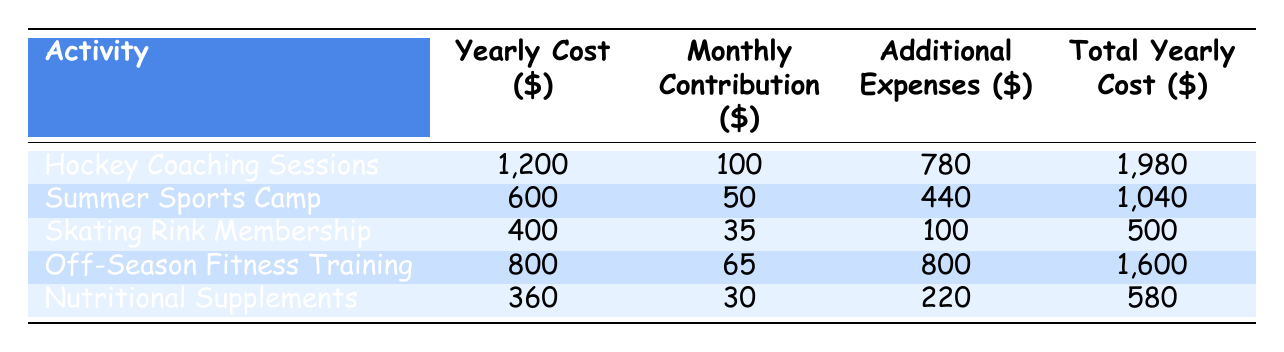What is the total yearly cost for Hockey Coaching Sessions? The table shows the total yearly cost for each activity. For Hockey Coaching Sessions, the total yearly cost is listed as 1980.
Answer: 1980 What is the monthly contribution required for the Skating Rink Membership? Referring to the table, the monthly contribution for the Skating Rink Membership is clearly stated as 35.
Answer: 35 Is the yearly cost for Summer Sports Camp less than the total yearly cost for Nutritional Supplements? The yearly cost for Summer Sports Camp is 600, and the total yearly cost for Nutritional Supplements is 580. Since 600 is greater than 580, the statement is false.
Answer: No What are the additional expenses associated with Off-Season Fitness Training? The table provides the breakdown of additional expenses for Off-Season Fitness Training, which includes Gym Memberships (300), Personal Trainer (400), and Training Equipment (100). Adding these gives a total of 800.
Answer: 800 Which activity has the highest total yearly cost? To find the highest total yearly cost, we compare the total yearly costs for all activities: Hockey Coaching Sessions (1980), Summer Sports Camp (1040), Skating Rink Membership (500), Off-Season Fitness Training (1600), and Nutritional Supplements (580). The highest total is 1980 for Hockey Coaching Sessions.
Answer: Hockey Coaching Sessions What is the average monthly contribution across all activities? First, we need to add the monthly contributions for each activity: 100 (Hockey Coaching) + 50 (Summer Sports Camp) + 35 (Skating Rink) + 65 (Off-Season Training) + 30 (Nutritional Supplements) = 380. There are 5 activities, so the average monthly contribution is 380/5 = 76.
Answer: 76 Are the additional expenses for Nutritional Supplements greater than the additional expenses for Skating Rink Membership? The additional expenses for Nutritional Supplements total 220, while the additional expenses for Skating Rink Membership amount to 100. Since 220 is greater than 100, the statement is true.
Answer: Yes What is the combined total yearly cost for both Hockey Coaching Sessions and Off-Season Fitness Training? The total yearly cost for Hockey Coaching Sessions is 1980 and for Off-Season Fitness Training is 1600. The combined total is 1980 + 1600 = 3580.
Answer: 3580 Which activity has the lowest monthly contribution, and what is that amount? Looking at the monthly contributions, the Skating Rink Membership has the lowest monthly contribution at 35 compared to others (100, 50, 65, 30).
Answer: Skating Rink Membership, 35 